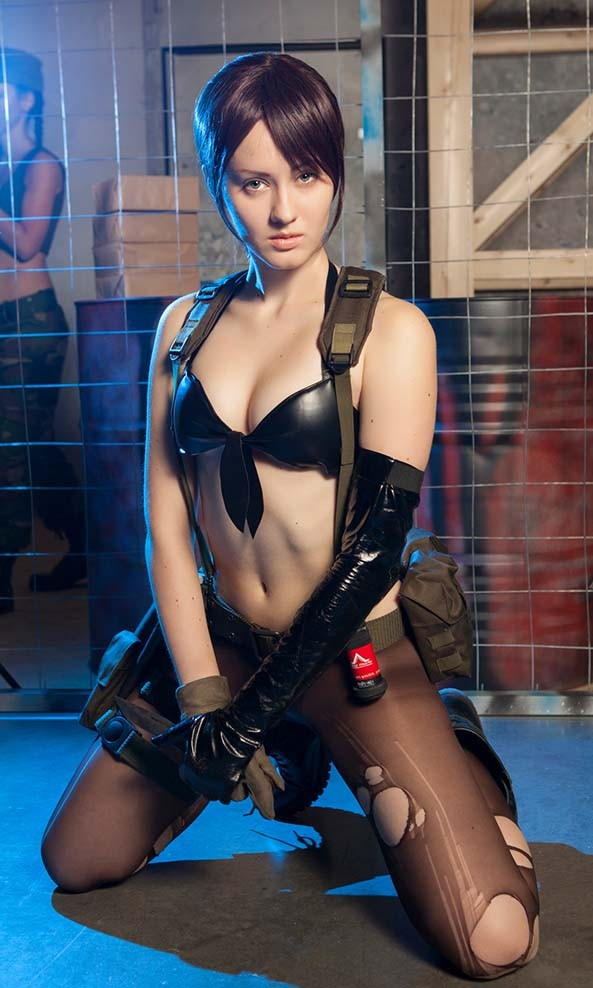Can you describe any other elements of the character's outfit that may give us insight into their abilities or role in their universe? Certainly, the character's attire is both functional and tactical. The holster straps and gloves suggest readiness for combat, while the choice of dark colors and a fitted ensemble allows for stealth and agility. The reinforced knee patches and worn texture of the clothing indicate frequent engagement in groundwork or stealth maneuvers. This points to a character skilled in espionage or guerrilla tactics, adept at navigating treacherous terrains and perhaps specializing in missions that require a high level of physical prowess and discretion. 